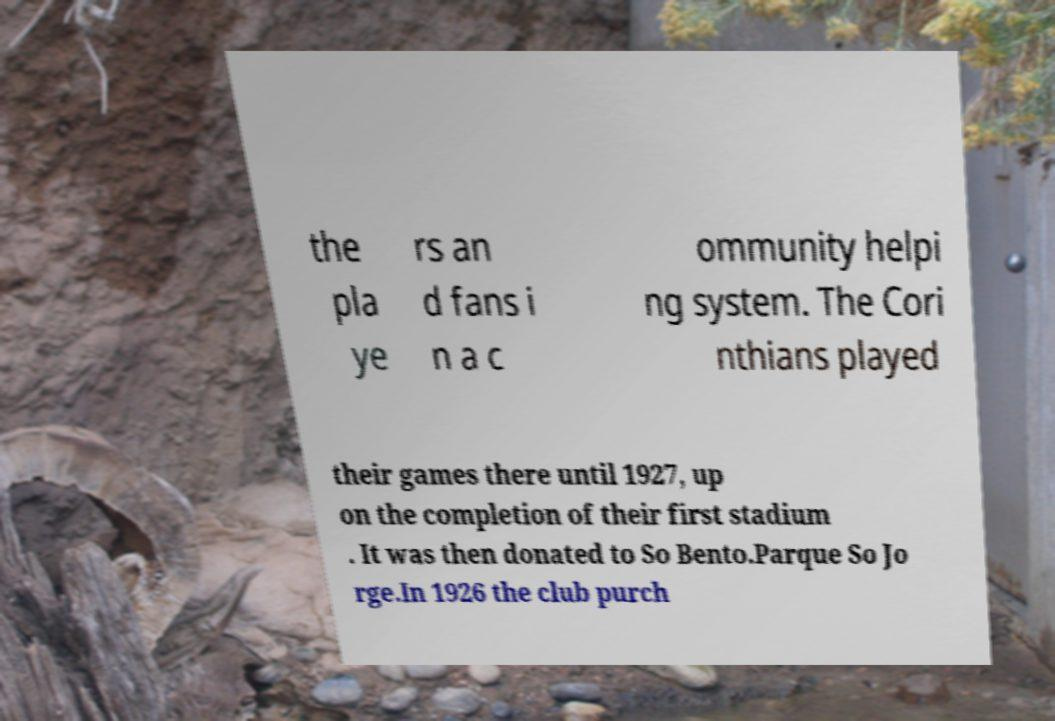Could you assist in decoding the text presented in this image and type it out clearly? the pla ye rs an d fans i n a c ommunity helpi ng system. The Cori nthians played their games there until 1927, up on the completion of their first stadium . It was then donated to So Bento.Parque So Jo rge.In 1926 the club purch 